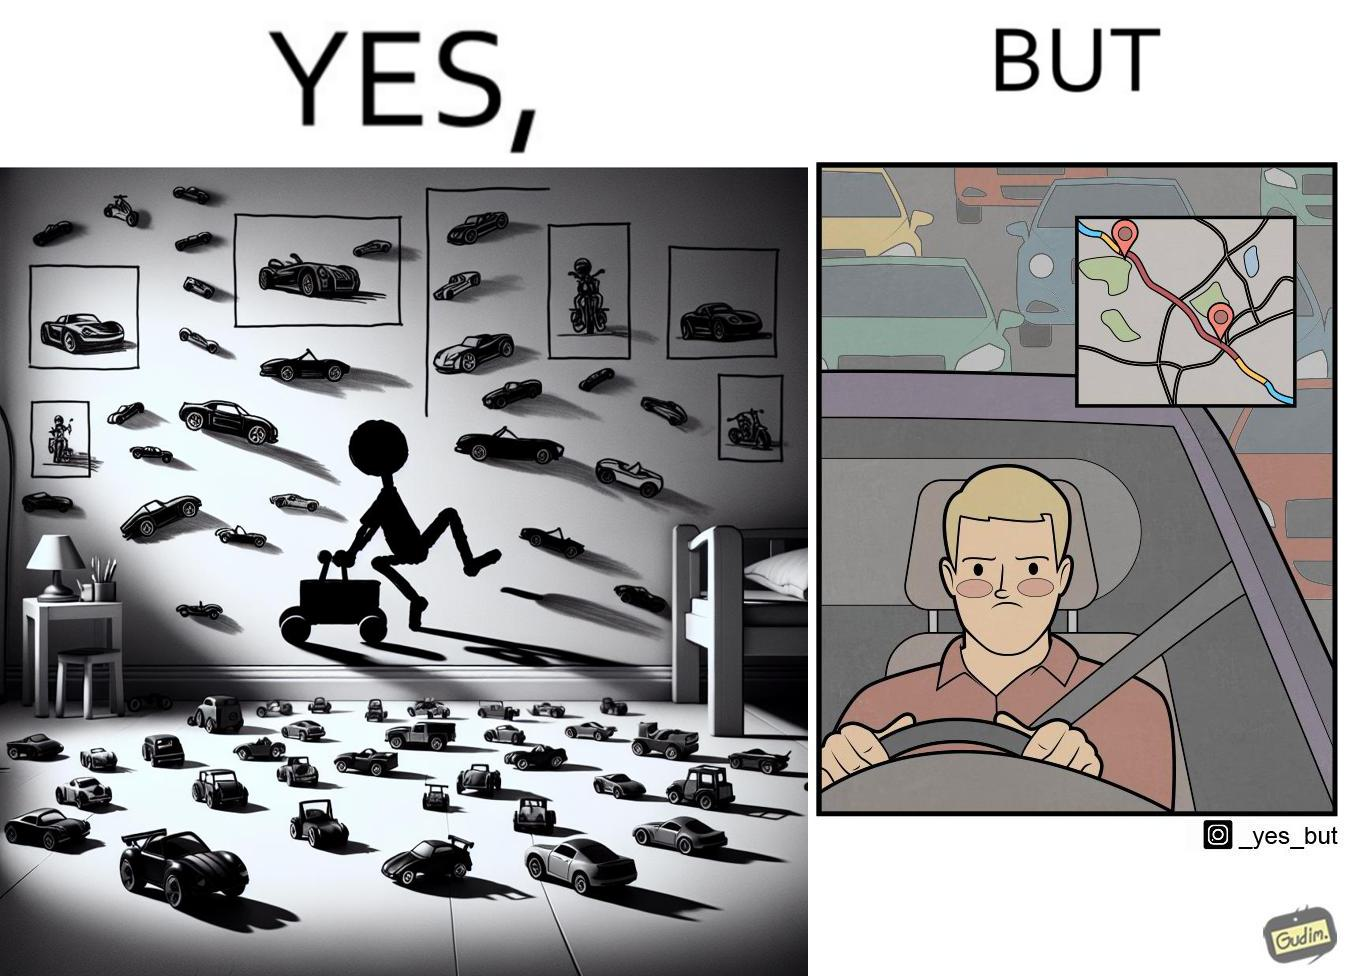Describe the satirical element in this image. The image is funny beaucse while the person as a child enjoyed being around cars, had various small toy cars and even rode a bigger toy car, as as grown up he does not enjoy being in a car during a traffic jam while he is driving . 